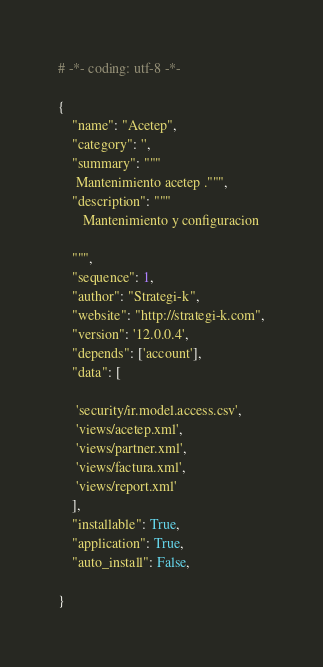Convert code to text. <code><loc_0><loc_0><loc_500><loc_500><_Python_># -*- coding: utf-8 -*-

{
    "name": "Acetep",
    "category": '',
    "summary": """
     Mantenimiento acetep .""",
    "description": """
	   Mantenimiento y configuracion

    """,
    "sequence": 1,
    "author": "Strategi-k",
    "website": "http://strategi-k.com",
    "version": '12.0.0.4',
    "depends": ['account'],
    "data": [
    
     'security/ir.model.access.csv',
     'views/acetep.xml',
     'views/partner.xml',
     'views/factura.xml',
     'views/report.xml'
    ],
    "installable": True,
    "application": True,
    "auto_install": False,

}
</code> 